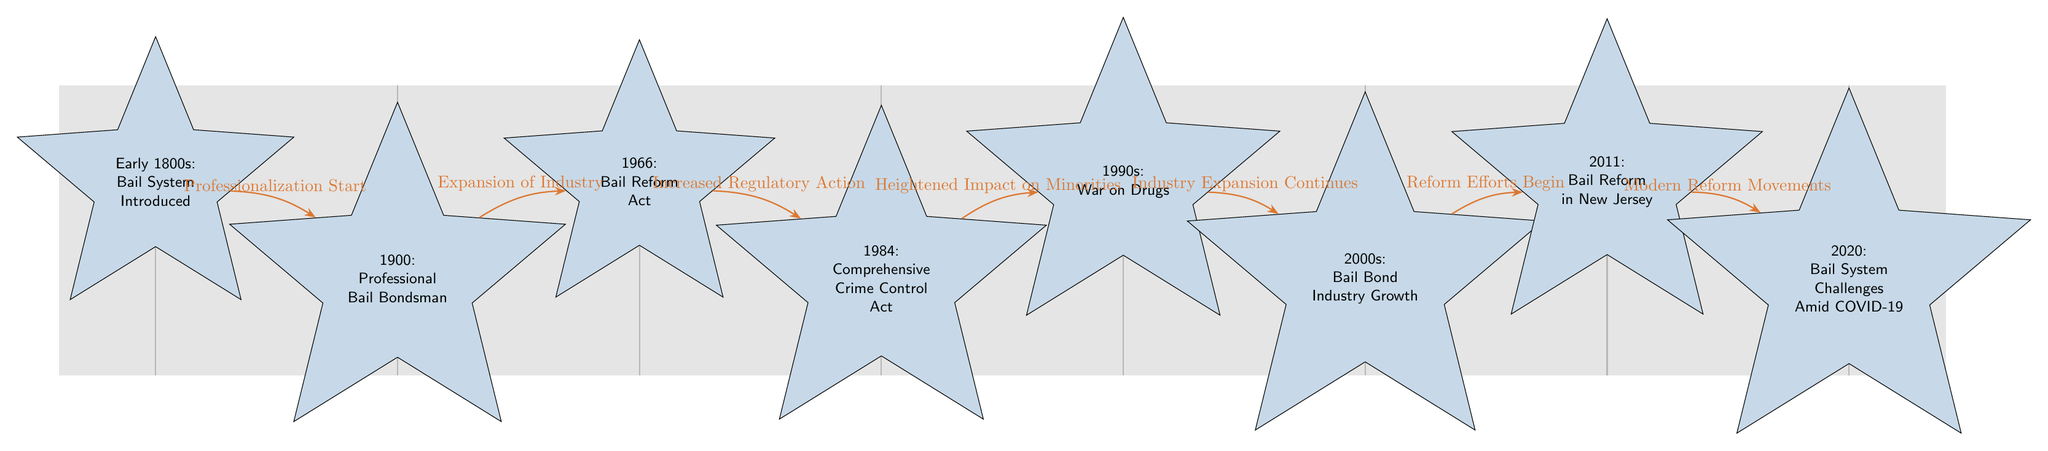What year was the Bail Reform Act introduced? The diagram shows a node specifically labeled "1966: Bail Reform Act." By looking at this node, we can directly find the corresponding year mentioned.
Answer: 1966 How many nodes are present in the diagram? By counting each star node on the diagram, we see that there are a total of eight nodes labeled with significant legislative dates and events related to the bail bond industry.
Answer: 8 What significant event happened in 1984? The node labeled "1984: Comprehensive Crime Control Act" indicates the significant event that took place in that year, which is clearly stated in the diagram.
Answer: Comprehensive Crime Control Act What connection is indicated between the 2000s and 2011? The diagram shows an edge labeled "Reform Efforts Begin" connecting the node for the 2000s to the node for 2011, indicating the relationship or progress from one event to the next.
Answer: Reform Efforts Begin What was the impact on minorities noted during the 1990s? The edge labeled "Heightened Impact on Minorities" connects the node for 1984 to the node for the 1990s, indicating the specific way in which the bail bond industry began to affect minorities during that period.
Answer: Heightened Impact on Minorities What trend is seen from the early 1800s to the 2000s? Looking at the timeline from the node "Early 1800s: Bail System Introduced" to "2000s: Bail Bond Industry Growth," we observe a consistent pattern of expansion and professionalization of the bail bond industry.
Answer: Expansion of Industry Which event marks the start of modern reform movements? The diagram indicates that the connection from the 2011 node leads to "2020: Bail System Challenges Amid COVID-19," marking the beginning point of modern reform movements concerning the bail system.
Answer: Modern Reform Movements What significant legislation occurred in New Jersey? The node specifically labeled "2011: Bail Reform in New Jersey" refers to the law or reforms that were enacted in New Jersey during this year, clearly identifying this significant piece of legislation.
Answer: Bail Reform in New Jersey 